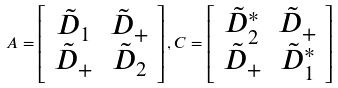<formula> <loc_0><loc_0><loc_500><loc_500>A = \left [ \begin{array} { c c } \tilde { D } _ { 1 } & \tilde { D } _ { + } \\ \tilde { D } _ { + } & \tilde { D } _ { 2 } \end{array} \right ] , C = \left [ \begin{array} { c c } \tilde { D } _ { 2 } ^ { * } & \tilde { D } _ { + } \\ \tilde { D } _ { + } & \tilde { D } _ { 1 } ^ { * } \end{array} \right ]</formula> 